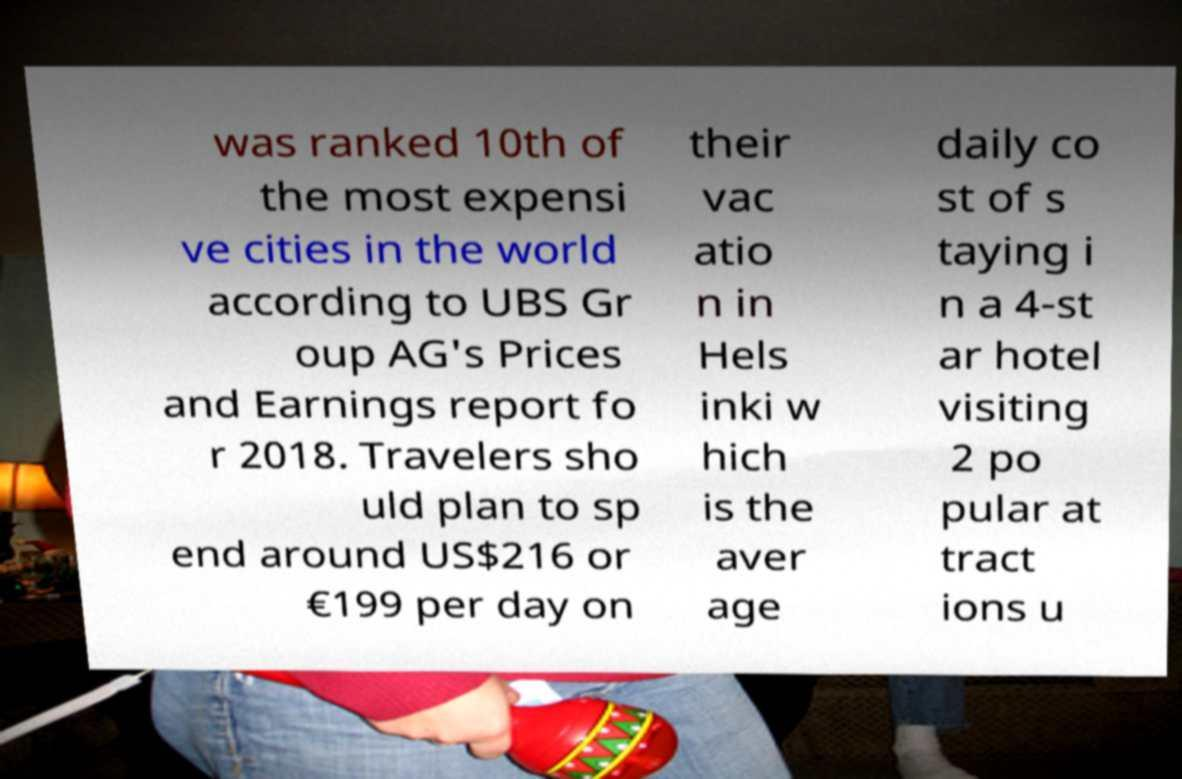Please identify and transcribe the text found in this image. was ranked 10th of the most expensi ve cities in the world according to UBS Gr oup AG's Prices and Earnings report fo r 2018. Travelers sho uld plan to sp end around US$216 or €199 per day on their vac atio n in Hels inki w hich is the aver age daily co st of s taying i n a 4-st ar hotel visiting 2 po pular at tract ions u 